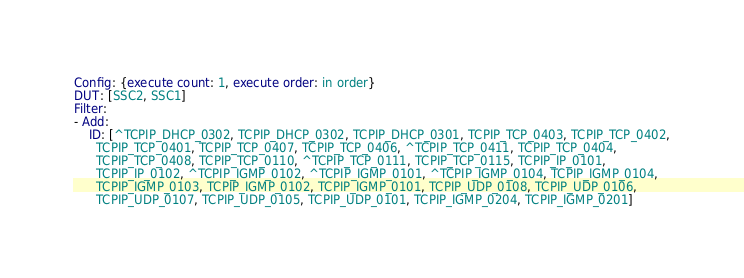<code> <loc_0><loc_0><loc_500><loc_500><_YAML_>Config: {execute count: 1, execute order: in order}
DUT: [SSC2, SSC1]
Filter:
- Add:
    ID: [^TCPIP_DHCP_0302, TCPIP_DHCP_0302, TCPIP_DHCP_0301, TCPIP_TCP_0403, TCPIP_TCP_0402,
      TCPIP_TCP_0401, TCPIP_TCP_0407, TCPIP_TCP_0406, ^TCPIP_TCP_0411, TCPIP_TCP_0404,
      TCPIP_TCP_0408, TCPIP_TCP_0110, ^TCPIP_TCP_0111, TCPIP_TCP_0115, TCPIP_IP_0101,
      TCPIP_IP_0102, ^TCPIP_IGMP_0102, ^TCPIP_IGMP_0101, ^TCPIP_IGMP_0104, TCPIP_IGMP_0104,
      TCPIP_IGMP_0103, TCPIP_IGMP_0102, TCPIP_IGMP_0101, TCPIP_UDP_0108, TCPIP_UDP_0106,
      TCPIP_UDP_0107, TCPIP_UDP_0105, TCPIP_UDP_0101, TCPIP_IGMP_0204, TCPIP_IGMP_0201]
</code> 